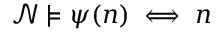Convert formula to latex. <formula><loc_0><loc_0><loc_500><loc_500>{ \mathcal { N } } \models \psi ( n ) \iff n</formula> 